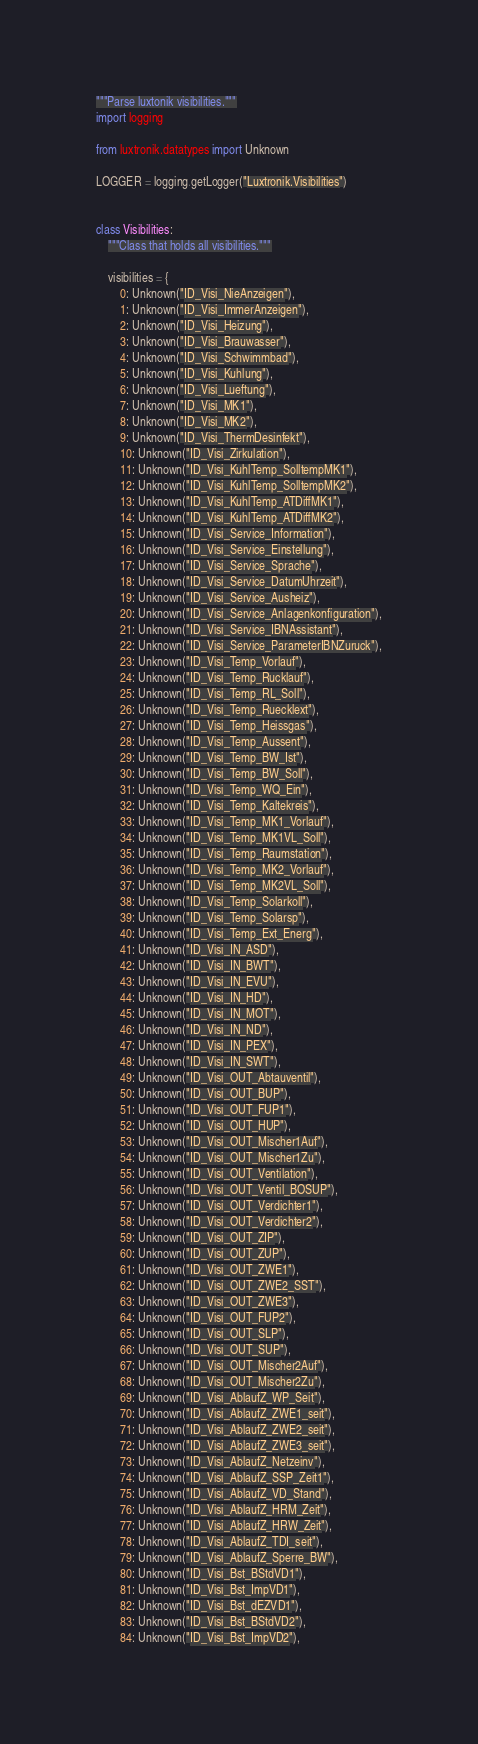Convert code to text. <code><loc_0><loc_0><loc_500><loc_500><_Python_>"""Parse luxtonik visibilities."""
import logging

from luxtronik.datatypes import Unknown

LOGGER = logging.getLogger("Luxtronik.Visibilities")


class Visibilities:
    """Class that holds all visibilities."""

    visibilities = {
        0: Unknown("ID_Visi_NieAnzeigen"),
        1: Unknown("ID_Visi_ImmerAnzeigen"),
        2: Unknown("ID_Visi_Heizung"),
        3: Unknown("ID_Visi_Brauwasser"),
        4: Unknown("ID_Visi_Schwimmbad"),
        5: Unknown("ID_Visi_Kuhlung"),
        6: Unknown("ID_Visi_Lueftung"),
        7: Unknown("ID_Visi_MK1"),
        8: Unknown("ID_Visi_MK2"),
        9: Unknown("ID_Visi_ThermDesinfekt"),
        10: Unknown("ID_Visi_Zirkulation"),
        11: Unknown("ID_Visi_KuhlTemp_SolltempMK1"),
        12: Unknown("ID_Visi_KuhlTemp_SolltempMK2"),
        13: Unknown("ID_Visi_KuhlTemp_ATDiffMK1"),
        14: Unknown("ID_Visi_KuhlTemp_ATDiffMK2"),
        15: Unknown("ID_Visi_Service_Information"),
        16: Unknown("ID_Visi_Service_Einstellung"),
        17: Unknown("ID_Visi_Service_Sprache"),
        18: Unknown("ID_Visi_Service_DatumUhrzeit"),
        19: Unknown("ID_Visi_Service_Ausheiz"),
        20: Unknown("ID_Visi_Service_Anlagenkonfiguration"),
        21: Unknown("ID_Visi_Service_IBNAssistant"),
        22: Unknown("ID_Visi_Service_ParameterIBNZuruck"),
        23: Unknown("ID_Visi_Temp_Vorlauf"),
        24: Unknown("ID_Visi_Temp_Rucklauf"),
        25: Unknown("ID_Visi_Temp_RL_Soll"),
        26: Unknown("ID_Visi_Temp_Ruecklext"),
        27: Unknown("ID_Visi_Temp_Heissgas"),
        28: Unknown("ID_Visi_Temp_Aussent"),
        29: Unknown("ID_Visi_Temp_BW_Ist"),
        30: Unknown("ID_Visi_Temp_BW_Soll"),
        31: Unknown("ID_Visi_Temp_WQ_Ein"),
        32: Unknown("ID_Visi_Temp_Kaltekreis"),
        33: Unknown("ID_Visi_Temp_MK1_Vorlauf"),
        34: Unknown("ID_Visi_Temp_MK1VL_Soll"),
        35: Unknown("ID_Visi_Temp_Raumstation"),
        36: Unknown("ID_Visi_Temp_MK2_Vorlauf"),
        37: Unknown("ID_Visi_Temp_MK2VL_Soll"),
        38: Unknown("ID_Visi_Temp_Solarkoll"),
        39: Unknown("ID_Visi_Temp_Solarsp"),
        40: Unknown("ID_Visi_Temp_Ext_Energ"),
        41: Unknown("ID_Visi_IN_ASD"),
        42: Unknown("ID_Visi_IN_BWT"),
        43: Unknown("ID_Visi_IN_EVU"),
        44: Unknown("ID_Visi_IN_HD"),
        45: Unknown("ID_Visi_IN_MOT"),
        46: Unknown("ID_Visi_IN_ND"),
        47: Unknown("ID_Visi_IN_PEX"),
        48: Unknown("ID_Visi_IN_SWT"),
        49: Unknown("ID_Visi_OUT_Abtauventil"),
        50: Unknown("ID_Visi_OUT_BUP"),
        51: Unknown("ID_Visi_OUT_FUP1"),
        52: Unknown("ID_Visi_OUT_HUP"),
        53: Unknown("ID_Visi_OUT_Mischer1Auf"),
        54: Unknown("ID_Visi_OUT_Mischer1Zu"),
        55: Unknown("ID_Visi_OUT_Ventilation"),
        56: Unknown("ID_Visi_OUT_Ventil_BOSUP"),
        57: Unknown("ID_Visi_OUT_Verdichter1"),
        58: Unknown("ID_Visi_OUT_Verdichter2"),
        59: Unknown("ID_Visi_OUT_ZIP"),
        60: Unknown("ID_Visi_OUT_ZUP"),
        61: Unknown("ID_Visi_OUT_ZWE1"),
        62: Unknown("ID_Visi_OUT_ZWE2_SST"),
        63: Unknown("ID_Visi_OUT_ZWE3"),
        64: Unknown("ID_Visi_OUT_FUP2"),
        65: Unknown("ID_Visi_OUT_SLP"),
        66: Unknown("ID_Visi_OUT_SUP"),
        67: Unknown("ID_Visi_OUT_Mischer2Auf"),
        68: Unknown("ID_Visi_OUT_Mischer2Zu"),
        69: Unknown("ID_Visi_AblaufZ_WP_Seit"),
        70: Unknown("ID_Visi_AblaufZ_ZWE1_seit"),
        71: Unknown("ID_Visi_AblaufZ_ZWE2_seit"),
        72: Unknown("ID_Visi_AblaufZ_ZWE3_seit"),
        73: Unknown("ID_Visi_AblaufZ_Netzeinv"),
        74: Unknown("ID_Visi_AblaufZ_SSP_Zeit1"),
        75: Unknown("ID_Visi_AblaufZ_VD_Stand"),
        76: Unknown("ID_Visi_AblaufZ_HRM_Zeit"),
        77: Unknown("ID_Visi_AblaufZ_HRW_Zeit"),
        78: Unknown("ID_Visi_AblaufZ_TDI_seit"),
        79: Unknown("ID_Visi_AblaufZ_Sperre_BW"),
        80: Unknown("ID_Visi_Bst_BStdVD1"),
        81: Unknown("ID_Visi_Bst_ImpVD1"),
        82: Unknown("ID_Visi_Bst_dEZVD1"),
        83: Unknown("ID_Visi_Bst_BStdVD2"),
        84: Unknown("ID_Visi_Bst_ImpVD2"),</code> 